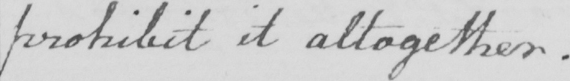Can you tell me what this handwritten text says? prohibit it altogether . 